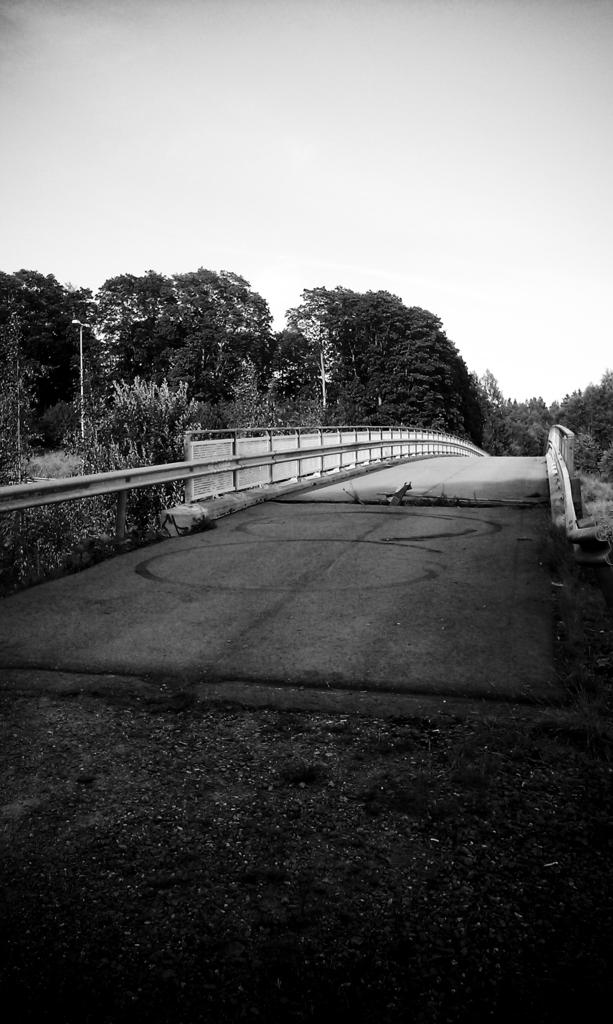What is the color scheme of the image? The image is black and white. What can be seen in the middle of the image? There is a road in the middle of the image. What type of vegetation is present on either side of the road? Trees are present on either side of the road. What is visible above the road in the image? The sky is visible above the road. Can you tell me how many questions the tiger is asking in the image? There is no tiger present in the image, and therefore no questions being asked. What type of donkey can be seen walking along the road in the image? There is no donkey present in the image; the main subject is the road. 